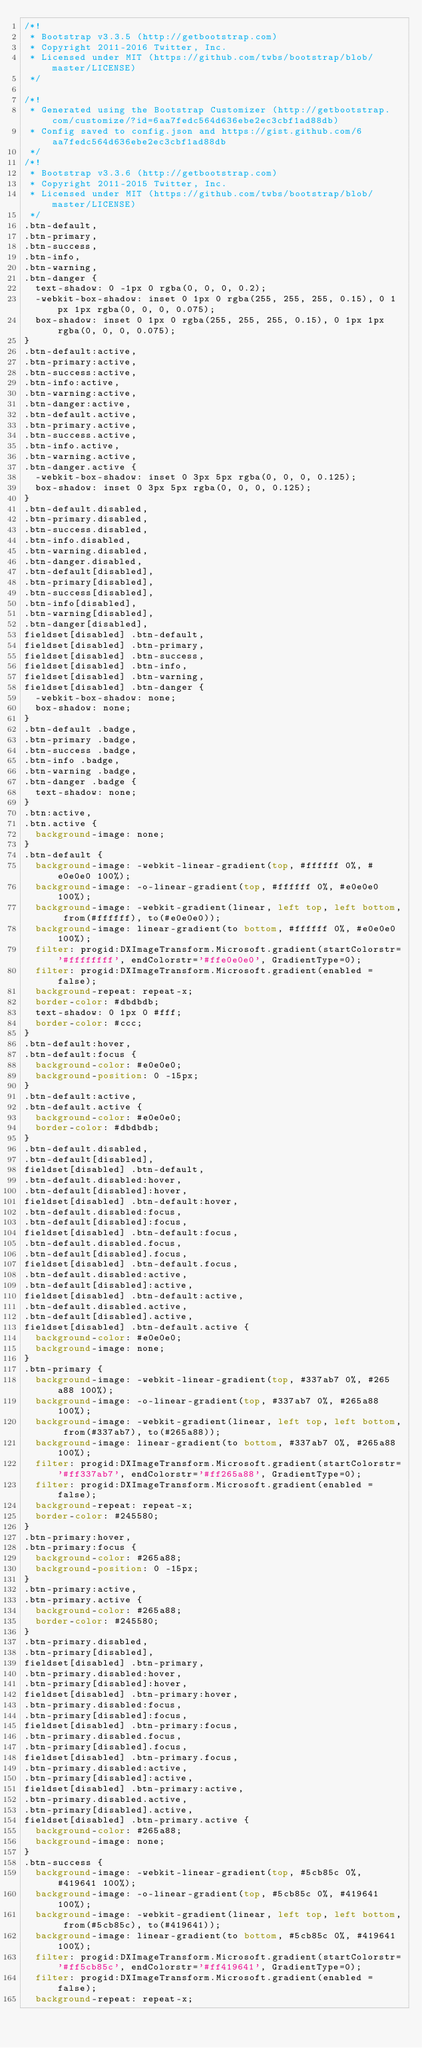<code> <loc_0><loc_0><loc_500><loc_500><_CSS_>/*!
 * Bootstrap v3.3.5 (http://getbootstrap.com)
 * Copyright 2011-2016 Twitter, Inc.
 * Licensed under MIT (https://github.com/twbs/bootstrap/blob/master/LICENSE)
 */

/*!
 * Generated using the Bootstrap Customizer (http://getbootstrap.com/customize/?id=6aa7fedc564d636ebe2ec3cbf1ad88db)
 * Config saved to config.json and https://gist.github.com/6aa7fedc564d636ebe2ec3cbf1ad88db
 */
/*!
 * Bootstrap v3.3.6 (http://getbootstrap.com)
 * Copyright 2011-2015 Twitter, Inc.
 * Licensed under MIT (https://github.com/twbs/bootstrap/blob/master/LICENSE)
 */
.btn-default,
.btn-primary,
.btn-success,
.btn-info,
.btn-warning,
.btn-danger {
  text-shadow: 0 -1px 0 rgba(0, 0, 0, 0.2);
  -webkit-box-shadow: inset 0 1px 0 rgba(255, 255, 255, 0.15), 0 1px 1px rgba(0, 0, 0, 0.075);
  box-shadow: inset 0 1px 0 rgba(255, 255, 255, 0.15), 0 1px 1px rgba(0, 0, 0, 0.075);
}
.btn-default:active,
.btn-primary:active,
.btn-success:active,
.btn-info:active,
.btn-warning:active,
.btn-danger:active,
.btn-default.active,
.btn-primary.active,
.btn-success.active,
.btn-info.active,
.btn-warning.active,
.btn-danger.active {
  -webkit-box-shadow: inset 0 3px 5px rgba(0, 0, 0, 0.125);
  box-shadow: inset 0 3px 5px rgba(0, 0, 0, 0.125);
}
.btn-default.disabled,
.btn-primary.disabled,
.btn-success.disabled,
.btn-info.disabled,
.btn-warning.disabled,
.btn-danger.disabled,
.btn-default[disabled],
.btn-primary[disabled],
.btn-success[disabled],
.btn-info[disabled],
.btn-warning[disabled],
.btn-danger[disabled],
fieldset[disabled] .btn-default,
fieldset[disabled] .btn-primary,
fieldset[disabled] .btn-success,
fieldset[disabled] .btn-info,
fieldset[disabled] .btn-warning,
fieldset[disabled] .btn-danger {
  -webkit-box-shadow: none;
  box-shadow: none;
}
.btn-default .badge,
.btn-primary .badge,
.btn-success .badge,
.btn-info .badge,
.btn-warning .badge,
.btn-danger .badge {
  text-shadow: none;
}
.btn:active,
.btn.active {
  background-image: none;
}
.btn-default {
  background-image: -webkit-linear-gradient(top, #ffffff 0%, #e0e0e0 100%);
  background-image: -o-linear-gradient(top, #ffffff 0%, #e0e0e0 100%);
  background-image: -webkit-gradient(linear, left top, left bottom, from(#ffffff), to(#e0e0e0));
  background-image: linear-gradient(to bottom, #ffffff 0%, #e0e0e0 100%);
  filter: progid:DXImageTransform.Microsoft.gradient(startColorstr='#ffffffff', endColorstr='#ffe0e0e0', GradientType=0);
  filter: progid:DXImageTransform.Microsoft.gradient(enabled = false);
  background-repeat: repeat-x;
  border-color: #dbdbdb;
  text-shadow: 0 1px 0 #fff;
  border-color: #ccc;
}
.btn-default:hover,
.btn-default:focus {
  background-color: #e0e0e0;
  background-position: 0 -15px;
}
.btn-default:active,
.btn-default.active {
  background-color: #e0e0e0;
  border-color: #dbdbdb;
}
.btn-default.disabled,
.btn-default[disabled],
fieldset[disabled] .btn-default,
.btn-default.disabled:hover,
.btn-default[disabled]:hover,
fieldset[disabled] .btn-default:hover,
.btn-default.disabled:focus,
.btn-default[disabled]:focus,
fieldset[disabled] .btn-default:focus,
.btn-default.disabled.focus,
.btn-default[disabled].focus,
fieldset[disabled] .btn-default.focus,
.btn-default.disabled:active,
.btn-default[disabled]:active,
fieldset[disabled] .btn-default:active,
.btn-default.disabled.active,
.btn-default[disabled].active,
fieldset[disabled] .btn-default.active {
  background-color: #e0e0e0;
  background-image: none;
}
.btn-primary {
  background-image: -webkit-linear-gradient(top, #337ab7 0%, #265a88 100%);
  background-image: -o-linear-gradient(top, #337ab7 0%, #265a88 100%);
  background-image: -webkit-gradient(linear, left top, left bottom, from(#337ab7), to(#265a88));
  background-image: linear-gradient(to bottom, #337ab7 0%, #265a88 100%);
  filter: progid:DXImageTransform.Microsoft.gradient(startColorstr='#ff337ab7', endColorstr='#ff265a88', GradientType=0);
  filter: progid:DXImageTransform.Microsoft.gradient(enabled = false);
  background-repeat: repeat-x;
  border-color: #245580;
}
.btn-primary:hover,
.btn-primary:focus {
  background-color: #265a88;
  background-position: 0 -15px;
}
.btn-primary:active,
.btn-primary.active {
  background-color: #265a88;
  border-color: #245580;
}
.btn-primary.disabled,
.btn-primary[disabled],
fieldset[disabled] .btn-primary,
.btn-primary.disabled:hover,
.btn-primary[disabled]:hover,
fieldset[disabled] .btn-primary:hover,
.btn-primary.disabled:focus,
.btn-primary[disabled]:focus,
fieldset[disabled] .btn-primary:focus,
.btn-primary.disabled.focus,
.btn-primary[disabled].focus,
fieldset[disabled] .btn-primary.focus,
.btn-primary.disabled:active,
.btn-primary[disabled]:active,
fieldset[disabled] .btn-primary:active,
.btn-primary.disabled.active,
.btn-primary[disabled].active,
fieldset[disabled] .btn-primary.active {
  background-color: #265a88;
  background-image: none;
}
.btn-success {
  background-image: -webkit-linear-gradient(top, #5cb85c 0%, #419641 100%);
  background-image: -o-linear-gradient(top, #5cb85c 0%, #419641 100%);
  background-image: -webkit-gradient(linear, left top, left bottom, from(#5cb85c), to(#419641));
  background-image: linear-gradient(to bottom, #5cb85c 0%, #419641 100%);
  filter: progid:DXImageTransform.Microsoft.gradient(startColorstr='#ff5cb85c', endColorstr='#ff419641', GradientType=0);
  filter: progid:DXImageTransform.Microsoft.gradient(enabled = false);
  background-repeat: repeat-x;</code> 